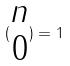<formula> <loc_0><loc_0><loc_500><loc_500>( \begin{matrix} n \\ 0 \end{matrix} ) = 1</formula> 